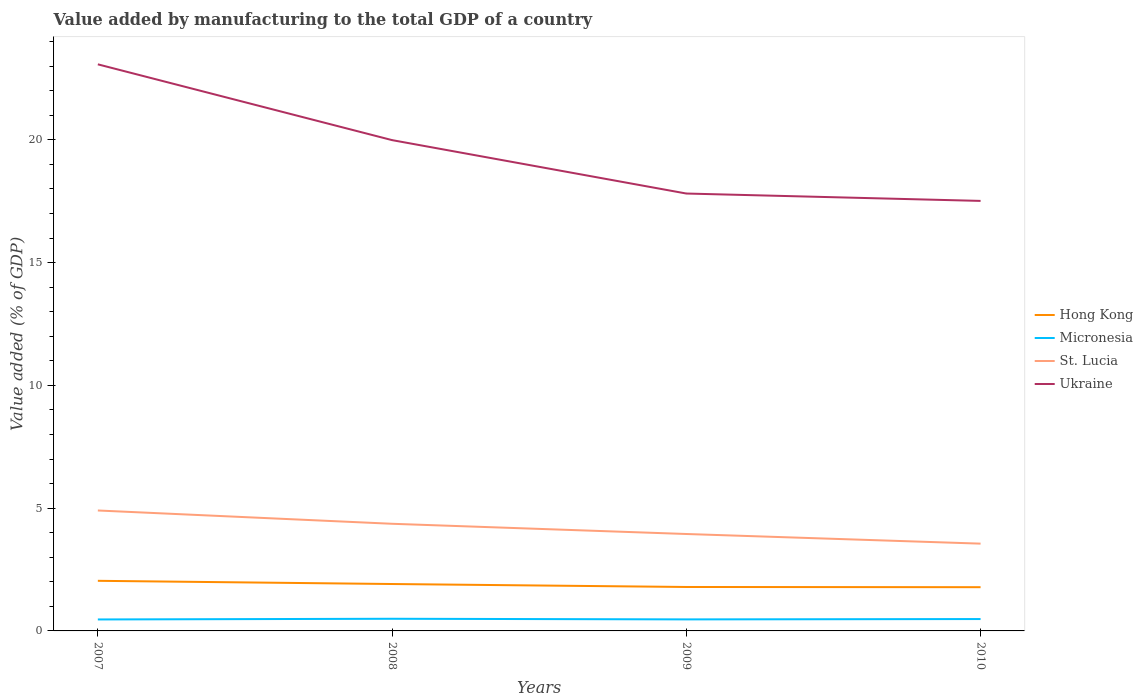Does the line corresponding to Ukraine intersect with the line corresponding to Hong Kong?
Offer a very short reply. No. Is the number of lines equal to the number of legend labels?
Your answer should be compact. Yes. Across all years, what is the maximum value added by manufacturing to the total GDP in Hong Kong?
Offer a very short reply. 1.78. In which year was the value added by manufacturing to the total GDP in St. Lucia maximum?
Provide a short and direct response. 2010. What is the total value added by manufacturing to the total GDP in Hong Kong in the graph?
Keep it short and to the point. 0.25. What is the difference between the highest and the second highest value added by manufacturing to the total GDP in St. Lucia?
Your response must be concise. 1.35. What is the difference between the highest and the lowest value added by manufacturing to the total GDP in Ukraine?
Make the answer very short. 2. Is the value added by manufacturing to the total GDP in Hong Kong strictly greater than the value added by manufacturing to the total GDP in Ukraine over the years?
Offer a very short reply. Yes. What is the difference between two consecutive major ticks on the Y-axis?
Your answer should be compact. 5. Are the values on the major ticks of Y-axis written in scientific E-notation?
Provide a short and direct response. No. Does the graph contain any zero values?
Your response must be concise. No. Where does the legend appear in the graph?
Your answer should be compact. Center right. How many legend labels are there?
Make the answer very short. 4. What is the title of the graph?
Keep it short and to the point. Value added by manufacturing to the total GDP of a country. What is the label or title of the Y-axis?
Offer a very short reply. Value added (% of GDP). What is the Value added (% of GDP) of Hong Kong in 2007?
Give a very brief answer. 2.04. What is the Value added (% of GDP) of Micronesia in 2007?
Provide a short and direct response. 0.47. What is the Value added (% of GDP) of St. Lucia in 2007?
Ensure brevity in your answer.  4.91. What is the Value added (% of GDP) in Ukraine in 2007?
Your answer should be very brief. 23.07. What is the Value added (% of GDP) of Hong Kong in 2008?
Provide a short and direct response. 1.91. What is the Value added (% of GDP) of Micronesia in 2008?
Ensure brevity in your answer.  0.49. What is the Value added (% of GDP) in St. Lucia in 2008?
Offer a very short reply. 4.36. What is the Value added (% of GDP) in Ukraine in 2008?
Offer a very short reply. 19.99. What is the Value added (% of GDP) of Hong Kong in 2009?
Ensure brevity in your answer.  1.79. What is the Value added (% of GDP) in Micronesia in 2009?
Offer a terse response. 0.47. What is the Value added (% of GDP) of St. Lucia in 2009?
Your answer should be very brief. 3.95. What is the Value added (% of GDP) of Ukraine in 2009?
Offer a terse response. 17.81. What is the Value added (% of GDP) of Hong Kong in 2010?
Your answer should be very brief. 1.78. What is the Value added (% of GDP) in Micronesia in 2010?
Provide a succinct answer. 0.48. What is the Value added (% of GDP) of St. Lucia in 2010?
Your response must be concise. 3.55. What is the Value added (% of GDP) of Ukraine in 2010?
Make the answer very short. 17.51. Across all years, what is the maximum Value added (% of GDP) of Hong Kong?
Provide a short and direct response. 2.04. Across all years, what is the maximum Value added (% of GDP) of Micronesia?
Offer a very short reply. 0.49. Across all years, what is the maximum Value added (% of GDP) in St. Lucia?
Provide a succinct answer. 4.91. Across all years, what is the maximum Value added (% of GDP) in Ukraine?
Ensure brevity in your answer.  23.07. Across all years, what is the minimum Value added (% of GDP) in Hong Kong?
Ensure brevity in your answer.  1.78. Across all years, what is the minimum Value added (% of GDP) of Micronesia?
Offer a terse response. 0.47. Across all years, what is the minimum Value added (% of GDP) of St. Lucia?
Give a very brief answer. 3.55. Across all years, what is the minimum Value added (% of GDP) in Ukraine?
Your answer should be compact. 17.51. What is the total Value added (% of GDP) of Hong Kong in the graph?
Keep it short and to the point. 7.52. What is the total Value added (% of GDP) in Micronesia in the graph?
Make the answer very short. 1.92. What is the total Value added (% of GDP) of St. Lucia in the graph?
Give a very brief answer. 16.77. What is the total Value added (% of GDP) of Ukraine in the graph?
Keep it short and to the point. 78.39. What is the difference between the Value added (% of GDP) in Hong Kong in 2007 and that in 2008?
Make the answer very short. 0.13. What is the difference between the Value added (% of GDP) of Micronesia in 2007 and that in 2008?
Your answer should be very brief. -0.03. What is the difference between the Value added (% of GDP) in St. Lucia in 2007 and that in 2008?
Provide a succinct answer. 0.54. What is the difference between the Value added (% of GDP) in Ukraine in 2007 and that in 2008?
Make the answer very short. 3.09. What is the difference between the Value added (% of GDP) of Hong Kong in 2007 and that in 2009?
Ensure brevity in your answer.  0.25. What is the difference between the Value added (% of GDP) in Micronesia in 2007 and that in 2009?
Ensure brevity in your answer.  -0. What is the difference between the Value added (% of GDP) in St. Lucia in 2007 and that in 2009?
Your answer should be very brief. 0.96. What is the difference between the Value added (% of GDP) of Ukraine in 2007 and that in 2009?
Your response must be concise. 5.26. What is the difference between the Value added (% of GDP) of Hong Kong in 2007 and that in 2010?
Your answer should be very brief. 0.26. What is the difference between the Value added (% of GDP) of Micronesia in 2007 and that in 2010?
Give a very brief answer. -0.02. What is the difference between the Value added (% of GDP) in St. Lucia in 2007 and that in 2010?
Give a very brief answer. 1.35. What is the difference between the Value added (% of GDP) of Ukraine in 2007 and that in 2010?
Make the answer very short. 5.56. What is the difference between the Value added (% of GDP) of Hong Kong in 2008 and that in 2009?
Your answer should be compact. 0.12. What is the difference between the Value added (% of GDP) in Micronesia in 2008 and that in 2009?
Provide a succinct answer. 0.03. What is the difference between the Value added (% of GDP) in St. Lucia in 2008 and that in 2009?
Give a very brief answer. 0.42. What is the difference between the Value added (% of GDP) in Ukraine in 2008 and that in 2009?
Your answer should be compact. 2.17. What is the difference between the Value added (% of GDP) in Hong Kong in 2008 and that in 2010?
Make the answer very short. 0.13. What is the difference between the Value added (% of GDP) of Micronesia in 2008 and that in 2010?
Provide a short and direct response. 0.01. What is the difference between the Value added (% of GDP) of St. Lucia in 2008 and that in 2010?
Keep it short and to the point. 0.81. What is the difference between the Value added (% of GDP) of Ukraine in 2008 and that in 2010?
Keep it short and to the point. 2.48. What is the difference between the Value added (% of GDP) in Hong Kong in 2009 and that in 2010?
Offer a terse response. 0.01. What is the difference between the Value added (% of GDP) in Micronesia in 2009 and that in 2010?
Provide a short and direct response. -0.01. What is the difference between the Value added (% of GDP) of St. Lucia in 2009 and that in 2010?
Provide a short and direct response. 0.39. What is the difference between the Value added (% of GDP) of Ukraine in 2009 and that in 2010?
Keep it short and to the point. 0.3. What is the difference between the Value added (% of GDP) of Hong Kong in 2007 and the Value added (% of GDP) of Micronesia in 2008?
Offer a terse response. 1.55. What is the difference between the Value added (% of GDP) of Hong Kong in 2007 and the Value added (% of GDP) of St. Lucia in 2008?
Your answer should be compact. -2.32. What is the difference between the Value added (% of GDP) in Hong Kong in 2007 and the Value added (% of GDP) in Ukraine in 2008?
Provide a succinct answer. -17.95. What is the difference between the Value added (% of GDP) of Micronesia in 2007 and the Value added (% of GDP) of St. Lucia in 2008?
Ensure brevity in your answer.  -3.9. What is the difference between the Value added (% of GDP) of Micronesia in 2007 and the Value added (% of GDP) of Ukraine in 2008?
Your answer should be very brief. -19.52. What is the difference between the Value added (% of GDP) in St. Lucia in 2007 and the Value added (% of GDP) in Ukraine in 2008?
Give a very brief answer. -15.08. What is the difference between the Value added (% of GDP) in Hong Kong in 2007 and the Value added (% of GDP) in Micronesia in 2009?
Offer a terse response. 1.57. What is the difference between the Value added (% of GDP) in Hong Kong in 2007 and the Value added (% of GDP) in St. Lucia in 2009?
Offer a terse response. -1.91. What is the difference between the Value added (% of GDP) of Hong Kong in 2007 and the Value added (% of GDP) of Ukraine in 2009?
Offer a very short reply. -15.77. What is the difference between the Value added (% of GDP) in Micronesia in 2007 and the Value added (% of GDP) in St. Lucia in 2009?
Provide a short and direct response. -3.48. What is the difference between the Value added (% of GDP) of Micronesia in 2007 and the Value added (% of GDP) of Ukraine in 2009?
Offer a terse response. -17.35. What is the difference between the Value added (% of GDP) of St. Lucia in 2007 and the Value added (% of GDP) of Ukraine in 2009?
Provide a short and direct response. -12.91. What is the difference between the Value added (% of GDP) of Hong Kong in 2007 and the Value added (% of GDP) of Micronesia in 2010?
Provide a succinct answer. 1.56. What is the difference between the Value added (% of GDP) in Hong Kong in 2007 and the Value added (% of GDP) in St. Lucia in 2010?
Ensure brevity in your answer.  -1.51. What is the difference between the Value added (% of GDP) in Hong Kong in 2007 and the Value added (% of GDP) in Ukraine in 2010?
Offer a terse response. -15.47. What is the difference between the Value added (% of GDP) in Micronesia in 2007 and the Value added (% of GDP) in St. Lucia in 2010?
Keep it short and to the point. -3.09. What is the difference between the Value added (% of GDP) of Micronesia in 2007 and the Value added (% of GDP) of Ukraine in 2010?
Make the answer very short. -17.05. What is the difference between the Value added (% of GDP) of St. Lucia in 2007 and the Value added (% of GDP) of Ukraine in 2010?
Provide a short and direct response. -12.61. What is the difference between the Value added (% of GDP) in Hong Kong in 2008 and the Value added (% of GDP) in Micronesia in 2009?
Provide a succinct answer. 1.44. What is the difference between the Value added (% of GDP) of Hong Kong in 2008 and the Value added (% of GDP) of St. Lucia in 2009?
Your answer should be compact. -2.04. What is the difference between the Value added (% of GDP) in Hong Kong in 2008 and the Value added (% of GDP) in Ukraine in 2009?
Give a very brief answer. -15.9. What is the difference between the Value added (% of GDP) in Micronesia in 2008 and the Value added (% of GDP) in St. Lucia in 2009?
Provide a succinct answer. -3.45. What is the difference between the Value added (% of GDP) of Micronesia in 2008 and the Value added (% of GDP) of Ukraine in 2009?
Provide a succinct answer. -17.32. What is the difference between the Value added (% of GDP) of St. Lucia in 2008 and the Value added (% of GDP) of Ukraine in 2009?
Offer a terse response. -13.45. What is the difference between the Value added (% of GDP) in Hong Kong in 2008 and the Value added (% of GDP) in Micronesia in 2010?
Keep it short and to the point. 1.43. What is the difference between the Value added (% of GDP) of Hong Kong in 2008 and the Value added (% of GDP) of St. Lucia in 2010?
Make the answer very short. -1.64. What is the difference between the Value added (% of GDP) of Hong Kong in 2008 and the Value added (% of GDP) of Ukraine in 2010?
Keep it short and to the point. -15.6. What is the difference between the Value added (% of GDP) of Micronesia in 2008 and the Value added (% of GDP) of St. Lucia in 2010?
Provide a short and direct response. -3.06. What is the difference between the Value added (% of GDP) of Micronesia in 2008 and the Value added (% of GDP) of Ukraine in 2010?
Ensure brevity in your answer.  -17.02. What is the difference between the Value added (% of GDP) of St. Lucia in 2008 and the Value added (% of GDP) of Ukraine in 2010?
Provide a succinct answer. -13.15. What is the difference between the Value added (% of GDP) in Hong Kong in 2009 and the Value added (% of GDP) in Micronesia in 2010?
Ensure brevity in your answer.  1.31. What is the difference between the Value added (% of GDP) in Hong Kong in 2009 and the Value added (% of GDP) in St. Lucia in 2010?
Provide a succinct answer. -1.77. What is the difference between the Value added (% of GDP) of Hong Kong in 2009 and the Value added (% of GDP) of Ukraine in 2010?
Your response must be concise. -15.72. What is the difference between the Value added (% of GDP) of Micronesia in 2009 and the Value added (% of GDP) of St. Lucia in 2010?
Provide a succinct answer. -3.08. What is the difference between the Value added (% of GDP) in Micronesia in 2009 and the Value added (% of GDP) in Ukraine in 2010?
Give a very brief answer. -17.04. What is the difference between the Value added (% of GDP) in St. Lucia in 2009 and the Value added (% of GDP) in Ukraine in 2010?
Provide a short and direct response. -13.57. What is the average Value added (% of GDP) in Hong Kong per year?
Give a very brief answer. 1.88. What is the average Value added (% of GDP) of Micronesia per year?
Offer a very short reply. 0.48. What is the average Value added (% of GDP) in St. Lucia per year?
Give a very brief answer. 4.19. What is the average Value added (% of GDP) of Ukraine per year?
Make the answer very short. 19.6. In the year 2007, what is the difference between the Value added (% of GDP) in Hong Kong and Value added (% of GDP) in Micronesia?
Provide a short and direct response. 1.57. In the year 2007, what is the difference between the Value added (% of GDP) of Hong Kong and Value added (% of GDP) of St. Lucia?
Ensure brevity in your answer.  -2.86. In the year 2007, what is the difference between the Value added (% of GDP) of Hong Kong and Value added (% of GDP) of Ukraine?
Offer a very short reply. -21.03. In the year 2007, what is the difference between the Value added (% of GDP) of Micronesia and Value added (% of GDP) of St. Lucia?
Your answer should be very brief. -4.44. In the year 2007, what is the difference between the Value added (% of GDP) of Micronesia and Value added (% of GDP) of Ukraine?
Give a very brief answer. -22.61. In the year 2007, what is the difference between the Value added (% of GDP) of St. Lucia and Value added (% of GDP) of Ukraine?
Your answer should be compact. -18.17. In the year 2008, what is the difference between the Value added (% of GDP) of Hong Kong and Value added (% of GDP) of Micronesia?
Your answer should be compact. 1.42. In the year 2008, what is the difference between the Value added (% of GDP) in Hong Kong and Value added (% of GDP) in St. Lucia?
Ensure brevity in your answer.  -2.45. In the year 2008, what is the difference between the Value added (% of GDP) of Hong Kong and Value added (% of GDP) of Ukraine?
Ensure brevity in your answer.  -18.08. In the year 2008, what is the difference between the Value added (% of GDP) of Micronesia and Value added (% of GDP) of St. Lucia?
Offer a terse response. -3.87. In the year 2008, what is the difference between the Value added (% of GDP) of Micronesia and Value added (% of GDP) of Ukraine?
Give a very brief answer. -19.49. In the year 2008, what is the difference between the Value added (% of GDP) of St. Lucia and Value added (% of GDP) of Ukraine?
Offer a very short reply. -15.62. In the year 2009, what is the difference between the Value added (% of GDP) of Hong Kong and Value added (% of GDP) of Micronesia?
Your response must be concise. 1.32. In the year 2009, what is the difference between the Value added (% of GDP) in Hong Kong and Value added (% of GDP) in St. Lucia?
Keep it short and to the point. -2.16. In the year 2009, what is the difference between the Value added (% of GDP) in Hong Kong and Value added (% of GDP) in Ukraine?
Your response must be concise. -16.02. In the year 2009, what is the difference between the Value added (% of GDP) in Micronesia and Value added (% of GDP) in St. Lucia?
Give a very brief answer. -3.48. In the year 2009, what is the difference between the Value added (% of GDP) in Micronesia and Value added (% of GDP) in Ukraine?
Your response must be concise. -17.34. In the year 2009, what is the difference between the Value added (% of GDP) in St. Lucia and Value added (% of GDP) in Ukraine?
Keep it short and to the point. -13.87. In the year 2010, what is the difference between the Value added (% of GDP) in Hong Kong and Value added (% of GDP) in Micronesia?
Give a very brief answer. 1.3. In the year 2010, what is the difference between the Value added (% of GDP) of Hong Kong and Value added (% of GDP) of St. Lucia?
Your answer should be compact. -1.77. In the year 2010, what is the difference between the Value added (% of GDP) of Hong Kong and Value added (% of GDP) of Ukraine?
Offer a very short reply. -15.73. In the year 2010, what is the difference between the Value added (% of GDP) in Micronesia and Value added (% of GDP) in St. Lucia?
Offer a terse response. -3.07. In the year 2010, what is the difference between the Value added (% of GDP) in Micronesia and Value added (% of GDP) in Ukraine?
Offer a terse response. -17.03. In the year 2010, what is the difference between the Value added (% of GDP) in St. Lucia and Value added (% of GDP) in Ukraine?
Provide a short and direct response. -13.96. What is the ratio of the Value added (% of GDP) in Hong Kong in 2007 to that in 2008?
Give a very brief answer. 1.07. What is the ratio of the Value added (% of GDP) of Micronesia in 2007 to that in 2008?
Provide a succinct answer. 0.94. What is the ratio of the Value added (% of GDP) in St. Lucia in 2007 to that in 2008?
Offer a very short reply. 1.12. What is the ratio of the Value added (% of GDP) in Ukraine in 2007 to that in 2008?
Make the answer very short. 1.15. What is the ratio of the Value added (% of GDP) of Hong Kong in 2007 to that in 2009?
Provide a short and direct response. 1.14. What is the ratio of the Value added (% of GDP) of Micronesia in 2007 to that in 2009?
Ensure brevity in your answer.  0.99. What is the ratio of the Value added (% of GDP) in St. Lucia in 2007 to that in 2009?
Offer a very short reply. 1.24. What is the ratio of the Value added (% of GDP) of Ukraine in 2007 to that in 2009?
Offer a very short reply. 1.3. What is the ratio of the Value added (% of GDP) of Hong Kong in 2007 to that in 2010?
Keep it short and to the point. 1.15. What is the ratio of the Value added (% of GDP) in Micronesia in 2007 to that in 2010?
Keep it short and to the point. 0.97. What is the ratio of the Value added (% of GDP) in St. Lucia in 2007 to that in 2010?
Make the answer very short. 1.38. What is the ratio of the Value added (% of GDP) of Ukraine in 2007 to that in 2010?
Offer a terse response. 1.32. What is the ratio of the Value added (% of GDP) in Hong Kong in 2008 to that in 2009?
Provide a succinct answer. 1.07. What is the ratio of the Value added (% of GDP) in Micronesia in 2008 to that in 2009?
Give a very brief answer. 1.05. What is the ratio of the Value added (% of GDP) in St. Lucia in 2008 to that in 2009?
Your answer should be very brief. 1.11. What is the ratio of the Value added (% of GDP) of Ukraine in 2008 to that in 2009?
Make the answer very short. 1.12. What is the ratio of the Value added (% of GDP) in Hong Kong in 2008 to that in 2010?
Your answer should be very brief. 1.07. What is the ratio of the Value added (% of GDP) in Micronesia in 2008 to that in 2010?
Provide a succinct answer. 1.02. What is the ratio of the Value added (% of GDP) of St. Lucia in 2008 to that in 2010?
Offer a very short reply. 1.23. What is the ratio of the Value added (% of GDP) in Ukraine in 2008 to that in 2010?
Keep it short and to the point. 1.14. What is the ratio of the Value added (% of GDP) in Micronesia in 2009 to that in 2010?
Offer a very short reply. 0.97. What is the ratio of the Value added (% of GDP) in St. Lucia in 2009 to that in 2010?
Provide a short and direct response. 1.11. What is the ratio of the Value added (% of GDP) in Ukraine in 2009 to that in 2010?
Offer a very short reply. 1.02. What is the difference between the highest and the second highest Value added (% of GDP) in Hong Kong?
Your answer should be compact. 0.13. What is the difference between the highest and the second highest Value added (% of GDP) of Micronesia?
Provide a succinct answer. 0.01. What is the difference between the highest and the second highest Value added (% of GDP) of St. Lucia?
Your response must be concise. 0.54. What is the difference between the highest and the second highest Value added (% of GDP) in Ukraine?
Offer a very short reply. 3.09. What is the difference between the highest and the lowest Value added (% of GDP) in Hong Kong?
Offer a terse response. 0.26. What is the difference between the highest and the lowest Value added (% of GDP) of Micronesia?
Provide a short and direct response. 0.03. What is the difference between the highest and the lowest Value added (% of GDP) of St. Lucia?
Give a very brief answer. 1.35. What is the difference between the highest and the lowest Value added (% of GDP) in Ukraine?
Offer a terse response. 5.56. 